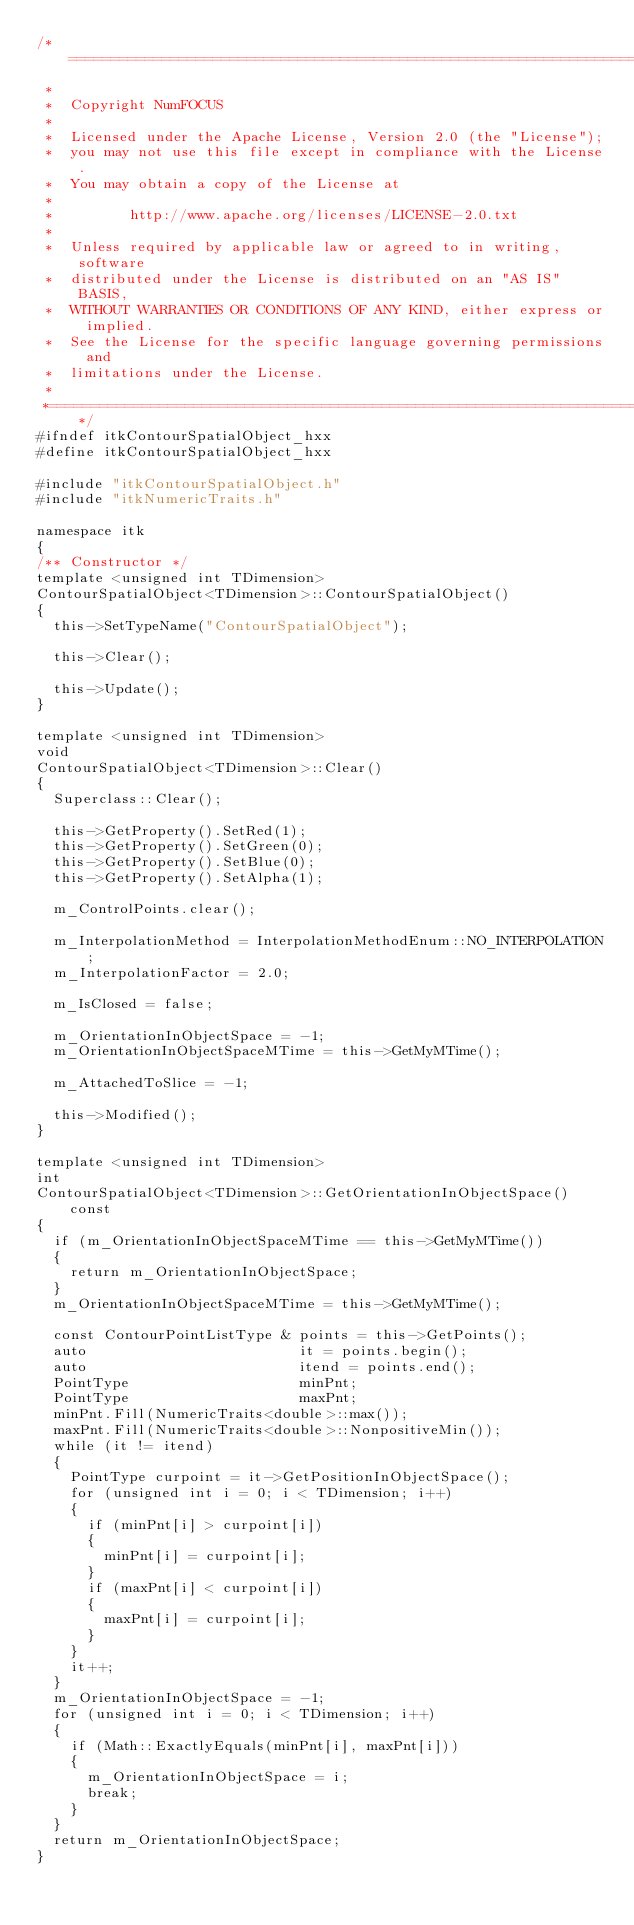Convert code to text. <code><loc_0><loc_0><loc_500><loc_500><_C++_>/*=========================================================================
 *
 *  Copyright NumFOCUS
 *
 *  Licensed under the Apache License, Version 2.0 (the "License");
 *  you may not use this file except in compliance with the License.
 *  You may obtain a copy of the License at
 *
 *         http://www.apache.org/licenses/LICENSE-2.0.txt
 *
 *  Unless required by applicable law or agreed to in writing, software
 *  distributed under the License is distributed on an "AS IS" BASIS,
 *  WITHOUT WARRANTIES OR CONDITIONS OF ANY KIND, either express or implied.
 *  See the License for the specific language governing permissions and
 *  limitations under the License.
 *
 *=========================================================================*/
#ifndef itkContourSpatialObject_hxx
#define itkContourSpatialObject_hxx

#include "itkContourSpatialObject.h"
#include "itkNumericTraits.h"

namespace itk
{
/** Constructor */
template <unsigned int TDimension>
ContourSpatialObject<TDimension>::ContourSpatialObject()
{
  this->SetTypeName("ContourSpatialObject");

  this->Clear();

  this->Update();
}

template <unsigned int TDimension>
void
ContourSpatialObject<TDimension>::Clear()
{
  Superclass::Clear();

  this->GetProperty().SetRed(1);
  this->GetProperty().SetGreen(0);
  this->GetProperty().SetBlue(0);
  this->GetProperty().SetAlpha(1);

  m_ControlPoints.clear();

  m_InterpolationMethod = InterpolationMethodEnum::NO_INTERPOLATION;
  m_InterpolationFactor = 2.0;

  m_IsClosed = false;

  m_OrientationInObjectSpace = -1;
  m_OrientationInObjectSpaceMTime = this->GetMyMTime();

  m_AttachedToSlice = -1;

  this->Modified();
}

template <unsigned int TDimension>
int
ContourSpatialObject<TDimension>::GetOrientationInObjectSpace() const
{
  if (m_OrientationInObjectSpaceMTime == this->GetMyMTime())
  {
    return m_OrientationInObjectSpace;
  }
  m_OrientationInObjectSpaceMTime = this->GetMyMTime();

  const ContourPointListType & points = this->GetPoints();
  auto                         it = points.begin();
  auto                         itend = points.end();
  PointType                    minPnt;
  PointType                    maxPnt;
  minPnt.Fill(NumericTraits<double>::max());
  maxPnt.Fill(NumericTraits<double>::NonpositiveMin());
  while (it != itend)
  {
    PointType curpoint = it->GetPositionInObjectSpace();
    for (unsigned int i = 0; i < TDimension; i++)
    {
      if (minPnt[i] > curpoint[i])
      {
        minPnt[i] = curpoint[i];
      }
      if (maxPnt[i] < curpoint[i])
      {
        maxPnt[i] = curpoint[i];
      }
    }
    it++;
  }
  m_OrientationInObjectSpace = -1;
  for (unsigned int i = 0; i < TDimension; i++)
  {
    if (Math::ExactlyEquals(minPnt[i], maxPnt[i]))
    {
      m_OrientationInObjectSpace = i;
      break;
    }
  }
  return m_OrientationInObjectSpace;
}
</code> 